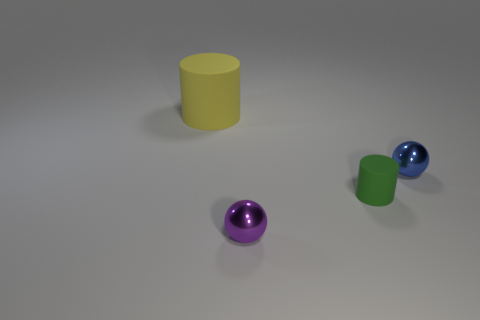Add 2 tiny purple cylinders. How many objects exist? 6 Add 2 large cylinders. How many large cylinders are left? 3 Add 1 brown matte things. How many brown matte things exist? 1 Subtract 0 cyan balls. How many objects are left? 4 Subtract all purple things. Subtract all purple objects. How many objects are left? 2 